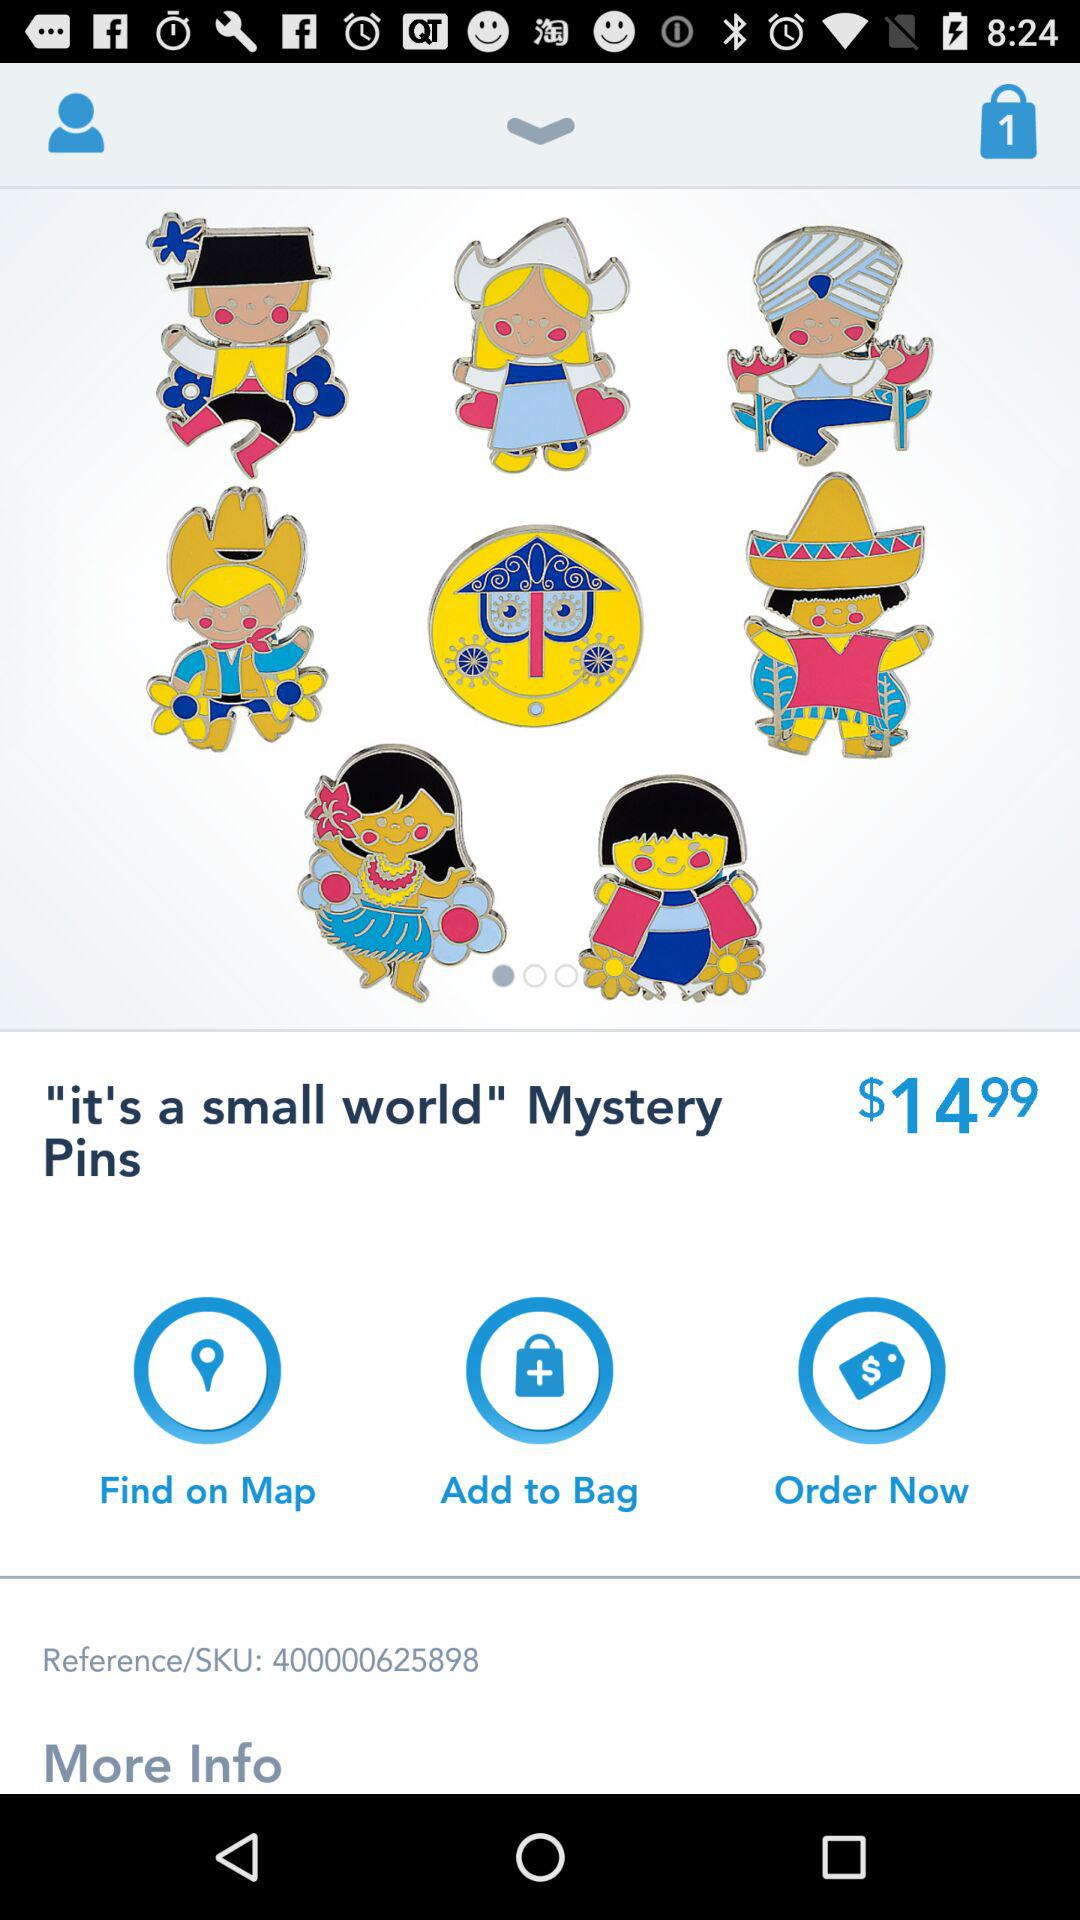What is the reference/SKU number? The reference/SKU number is 400000625898. 